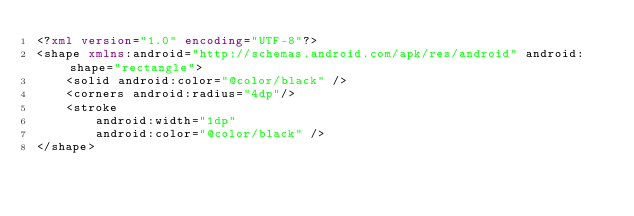<code> <loc_0><loc_0><loc_500><loc_500><_XML_><?xml version="1.0" encoding="UTF-8"?>
<shape xmlns:android="http://schemas.android.com/apk/res/android" android:shape="rectangle">
    <solid android:color="@color/black" />
    <corners android:radius="4dp"/>
    <stroke
        android:width="1dp"
        android:color="@color/black" />
</shape></code> 